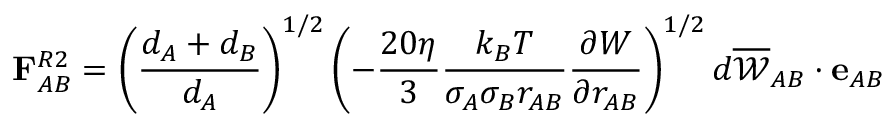<formula> <loc_0><loc_0><loc_500><loc_500>F _ { A B } ^ { R 2 } = \left ( \frac { d _ { A } + d _ { B } } { d _ { A } } \right ) ^ { 1 / 2 } \left ( - \frac { 2 0 \eta } { 3 } \frac { k _ { B } T } { \sigma _ { A } \sigma _ { B } r _ { A B } } \frac { \partial { W } } { \partial { r _ { A B } } } \right ) ^ { 1 / 2 } d \overline { { \ m a t h s c r { W } } } _ { A B } \cdot e _ { A B }</formula> 